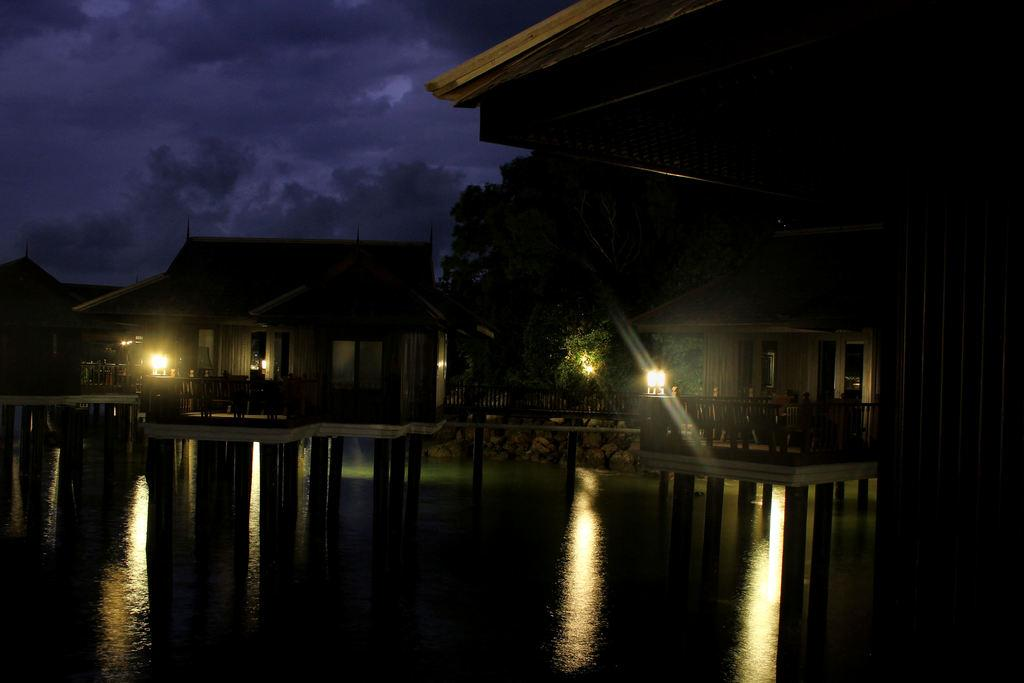What is located in front of the image? There is water in front of the image. What type of structures can be seen in the image? There are wooden houses in the image. What are the poles used for in the image? The purpose of the poles is not specified, but they are present in the image. What type of vegetation is visible in the image? Trees are visible in the image. What type of lighting is present in the image? Lamps are in the image. What type of architectural feature is present in the image? Railings are present in the image. What is visible in the sky at the top of the image? There are clouds in the sky at the top of the image. Can you tell me how many chess pieces are on the table in the image? There is no table or chess pieces present in the image. What type of ornament is hanging from the trees in the image? There are no ornaments hanging from the trees in the image; only trees, wooden houses, poles, lamps, railings, and clouds are present. 